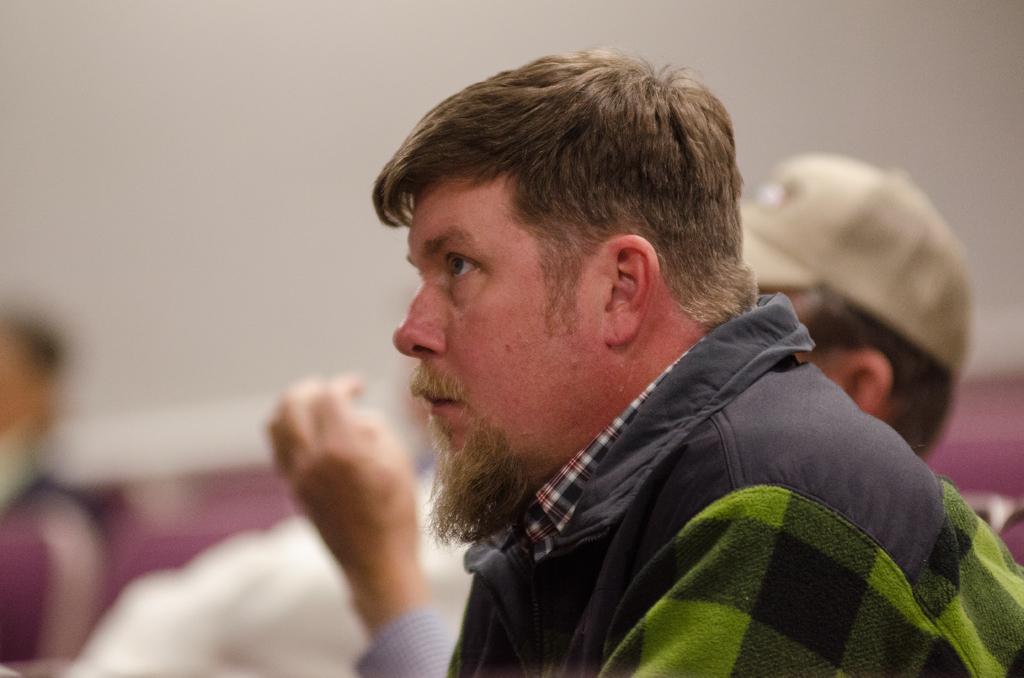In one or two sentences, can you explain what this image depicts? In the image we can see there is a man and he is wearing jacket. There are other people at the back and behind the image is little blurry. 